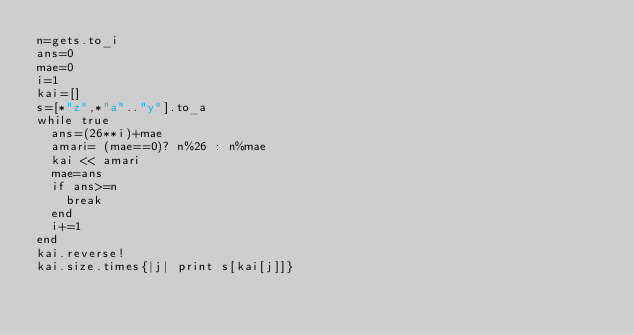Convert code to text. <code><loc_0><loc_0><loc_500><loc_500><_Ruby_>n=gets.to_i
ans=0
mae=0
i=1
kai=[]
s=[*"z",*"a".."y"].to_a
while true
  ans=(26**i)+mae
  amari= (mae==0)? n%26 : n%mae
  kai << amari
  mae=ans
  if ans>=n
    break
  end
  i+=1
end
kai.reverse!
kai.size.times{|j| print s[kai[j]]}
</code> 